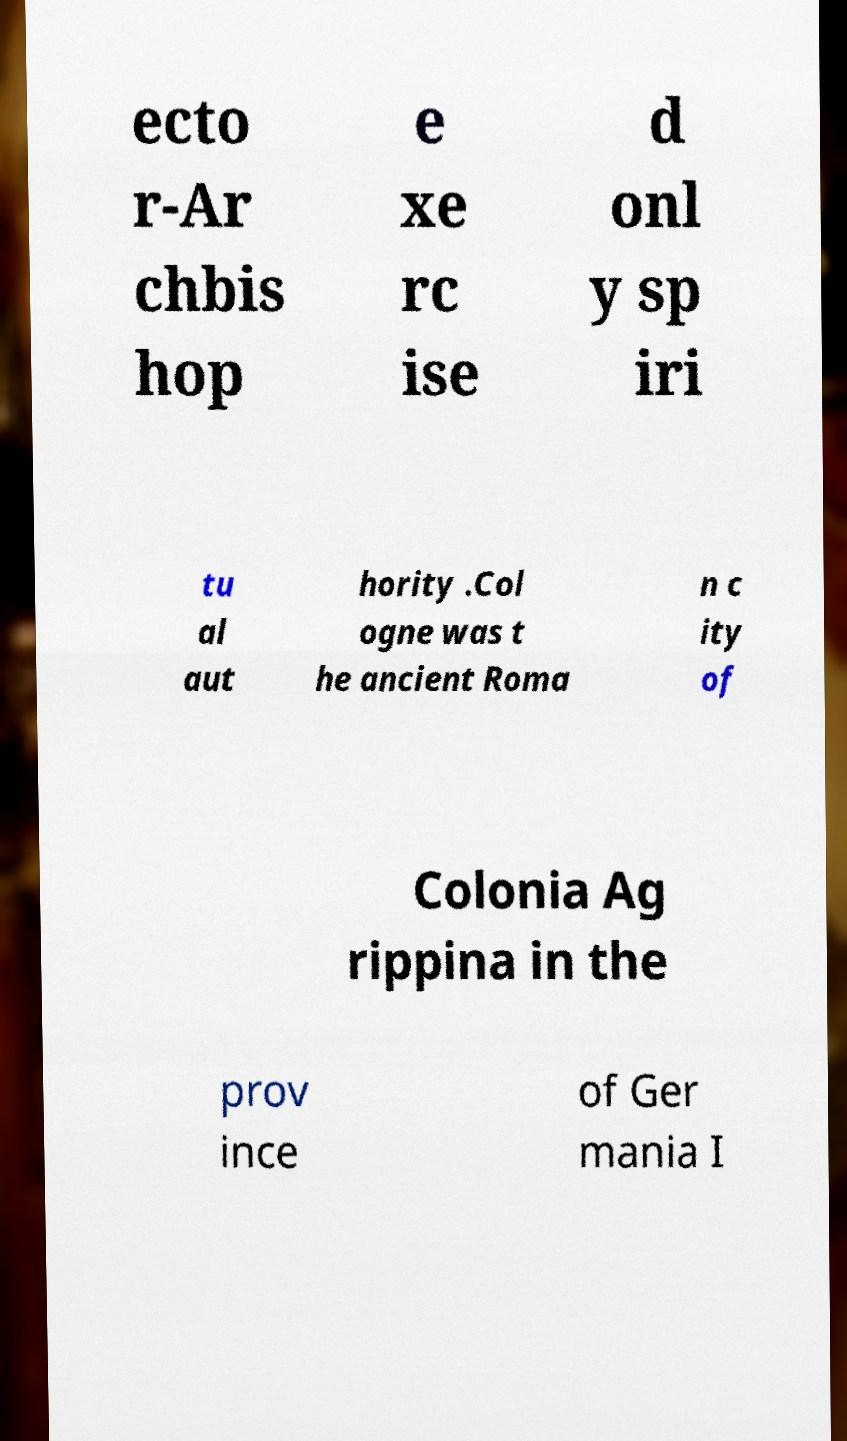For documentation purposes, I need the text within this image transcribed. Could you provide that? ecto r-Ar chbis hop e xe rc ise d onl y sp iri tu al aut hority .Col ogne was t he ancient Roma n c ity of Colonia Ag rippina in the prov ince of Ger mania I 